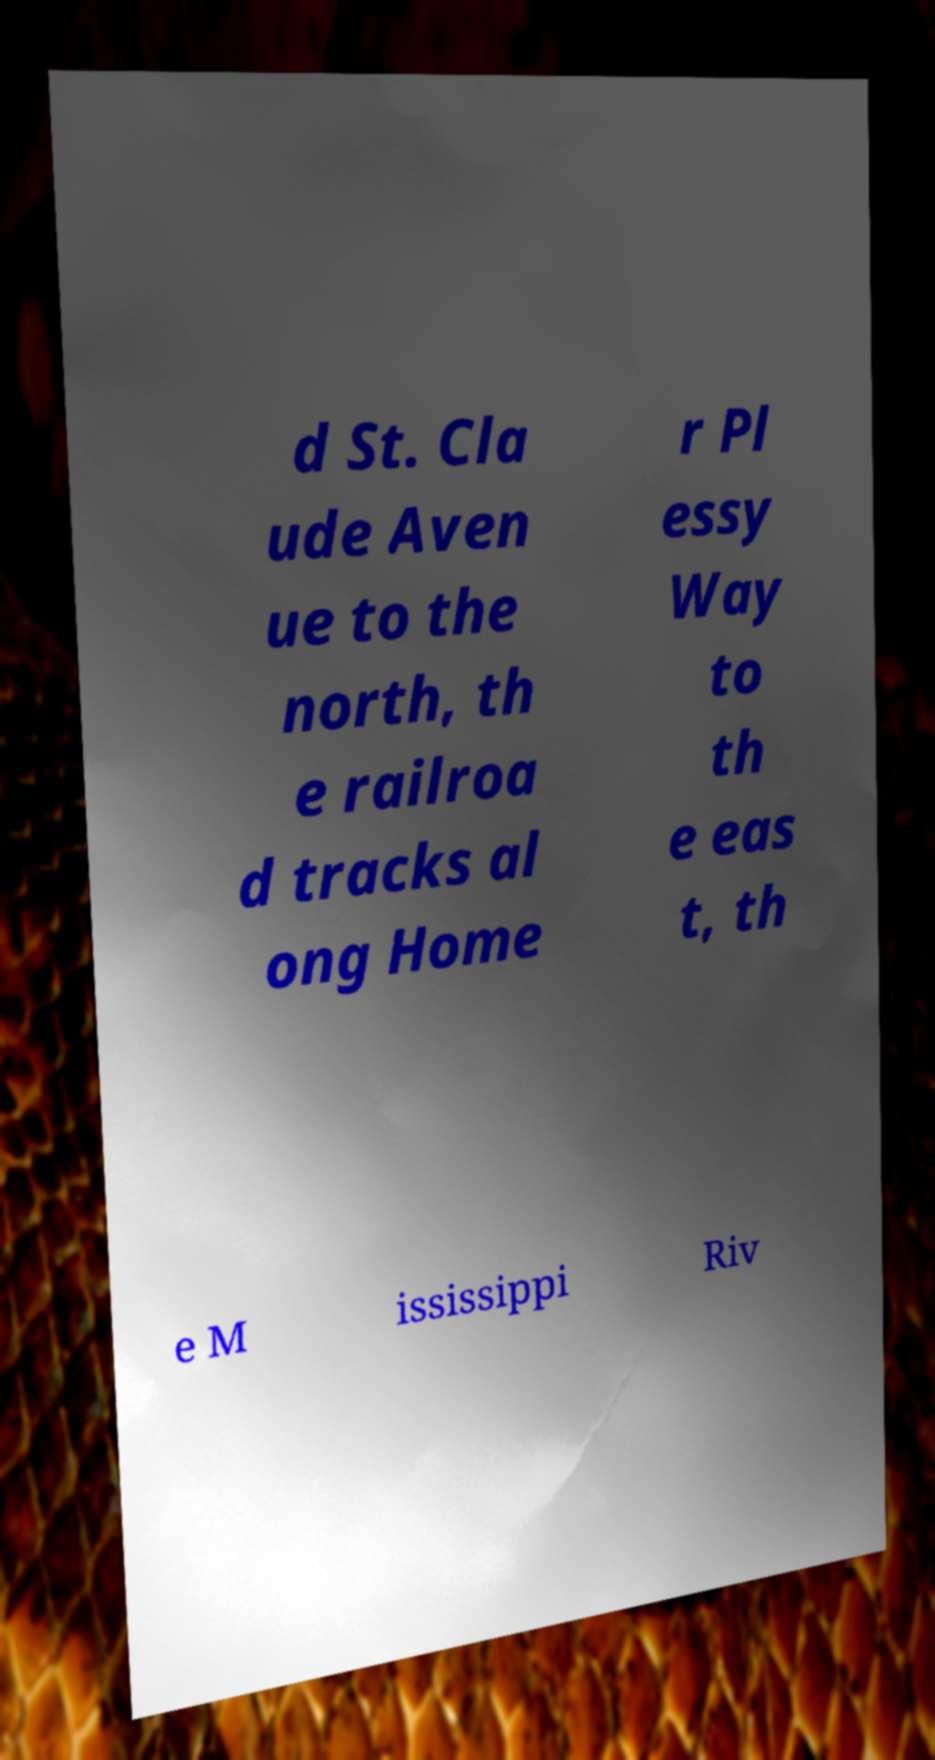Please identify and transcribe the text found in this image. d St. Cla ude Aven ue to the north, th e railroa d tracks al ong Home r Pl essy Way to th e eas t, th e M ississippi Riv 